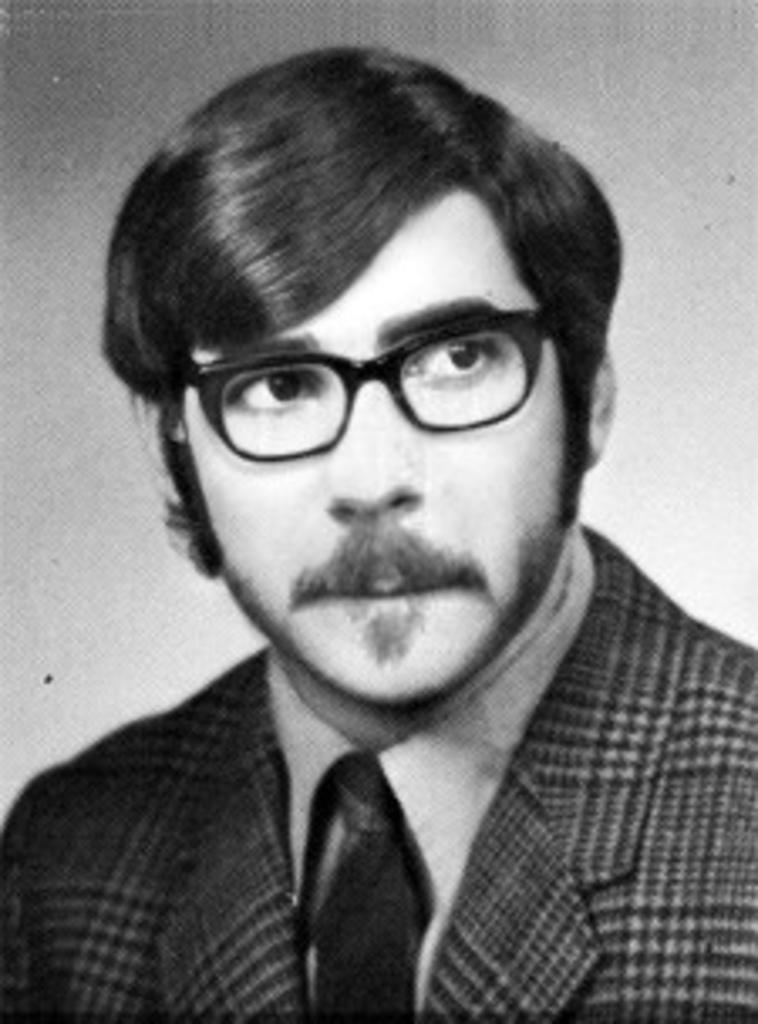What is the color scheme of the image? The image is black and white. Can you describe the main subject in the image? There is a person in the image. What is the person wearing? The person is wearing a suit. What type of rake is being used for destruction in the image? There is no rake or destruction present in the image; it features a person wearing a suit in a black and white setting. 